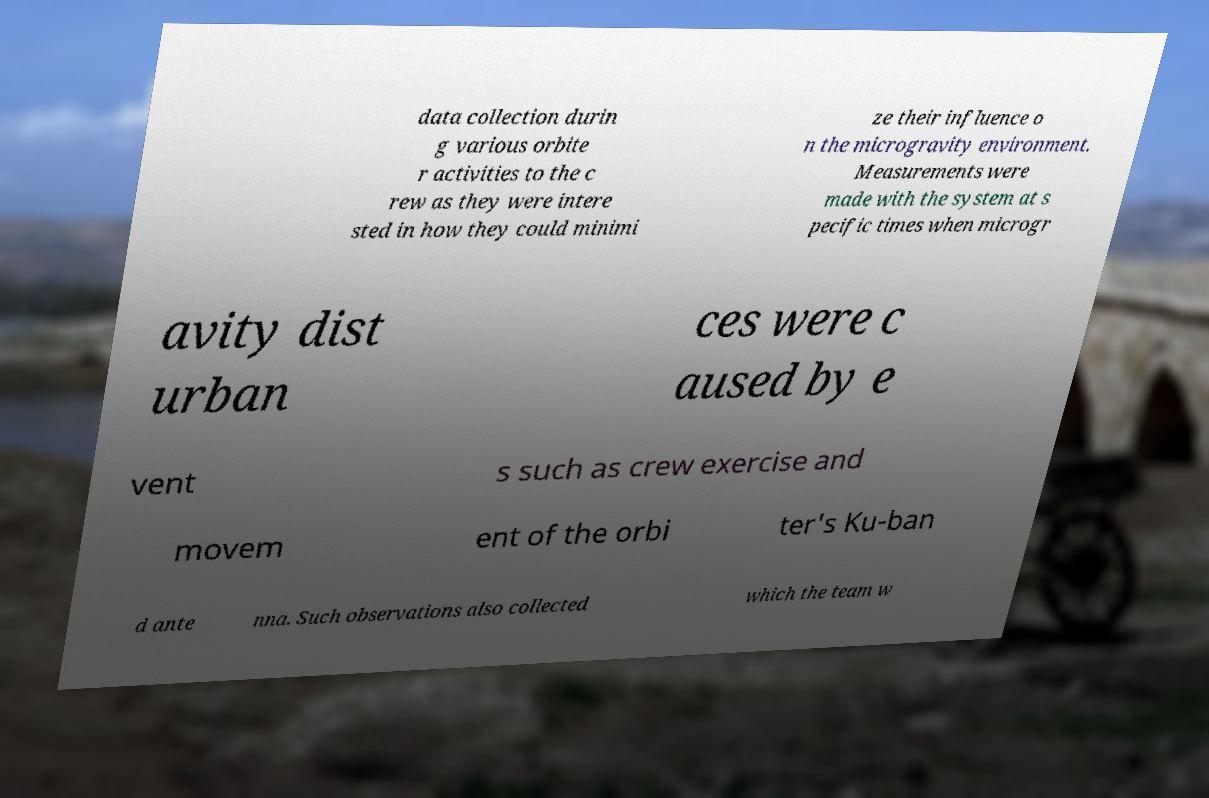For documentation purposes, I need the text within this image transcribed. Could you provide that? data collection durin g various orbite r activities to the c rew as they were intere sted in how they could minimi ze their influence o n the microgravity environment. Measurements were made with the system at s pecific times when microgr avity dist urban ces were c aused by e vent s such as crew exercise and movem ent of the orbi ter's Ku-ban d ante nna. Such observations also collected which the team w 